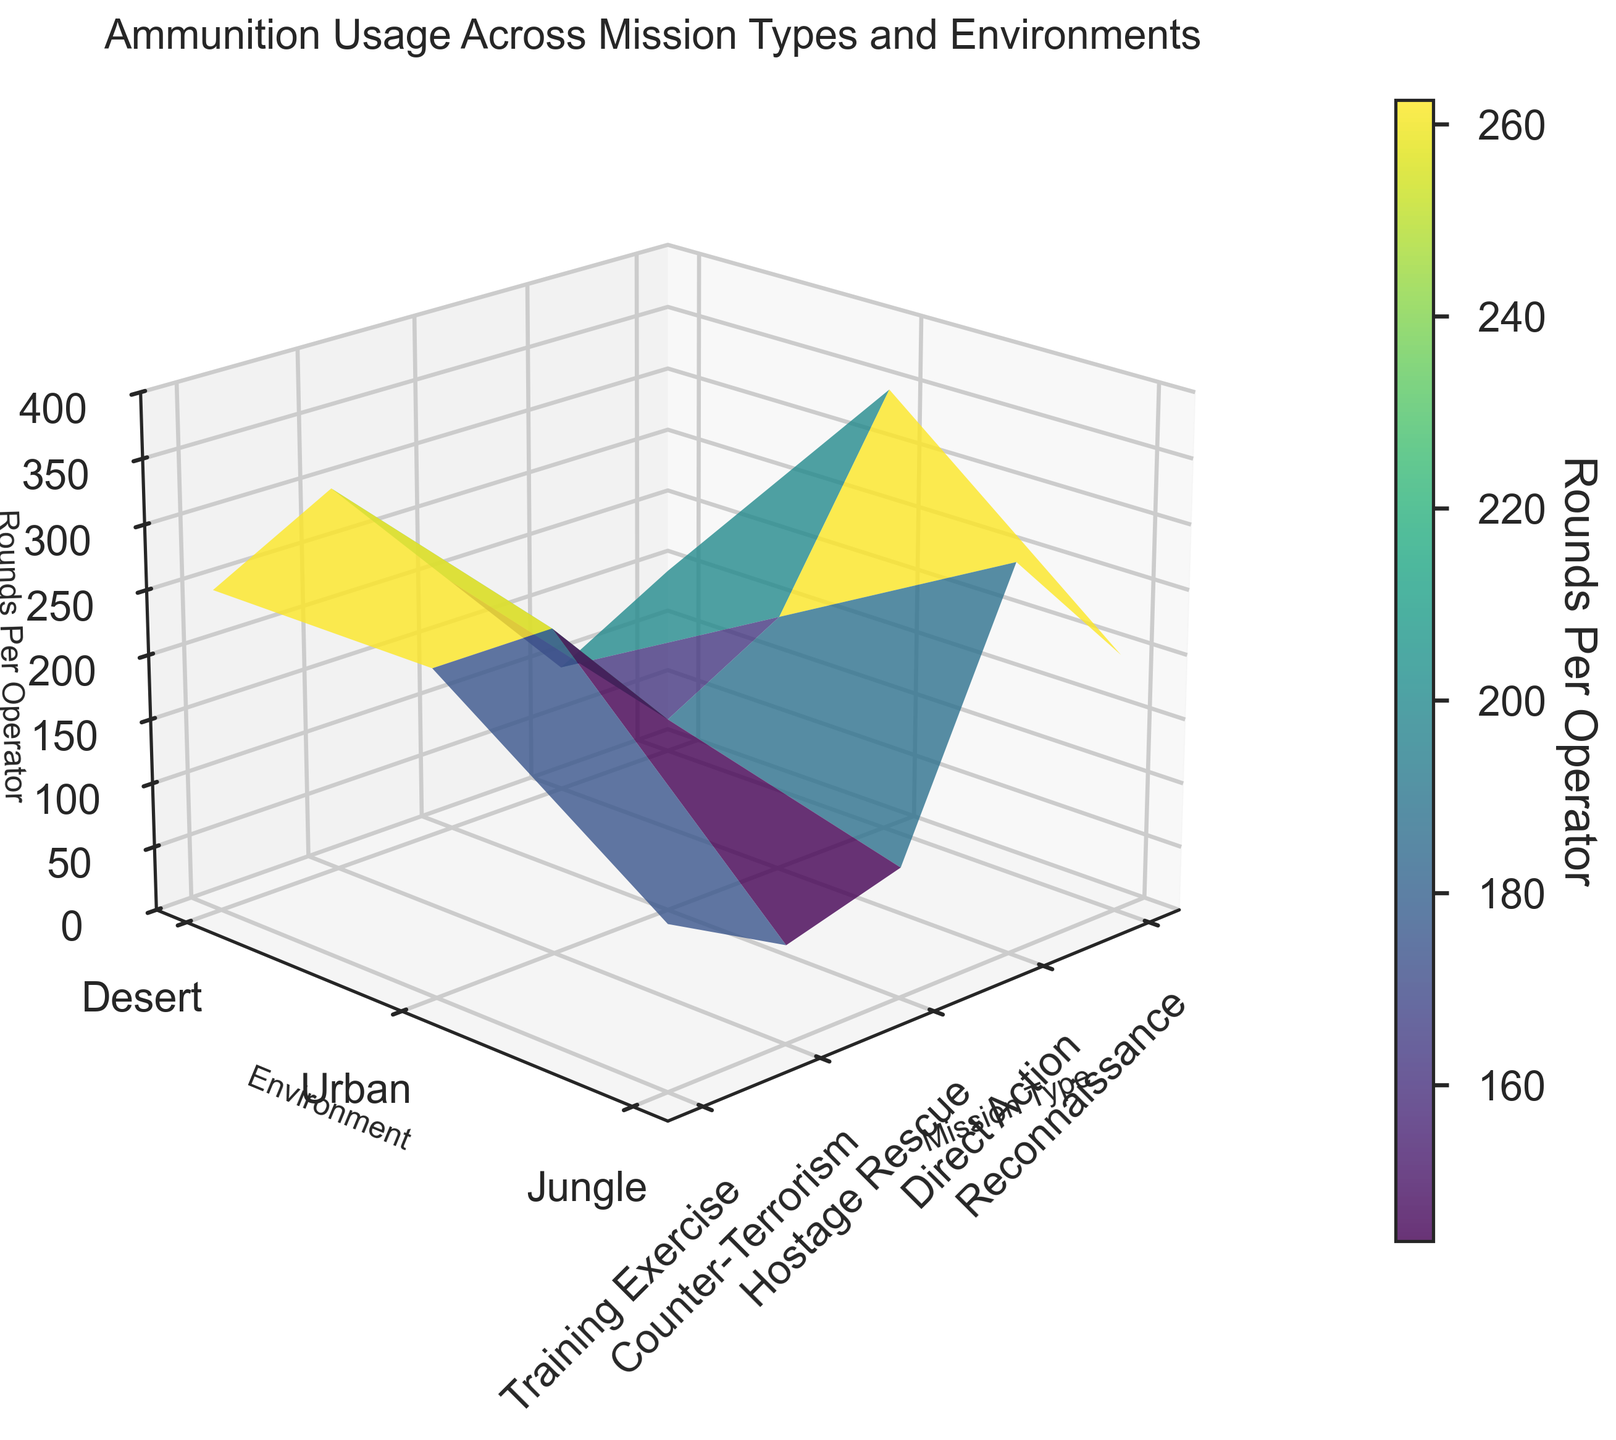What is the highest amount of rounds per operator in a jungle environment? Look for the peaks in the 'Jungle' section of the figure. The highest peak corresponds to the highest amount for the jungle. For 'Direct Action' in jungle, it’s at 350 rounds.
Answer: 350 Which mission type has the lowest ammunition usage in an urban environment? Identify the lowest points on the 'Urban' section of the plot. The 'Training Exercise' category has the lowest usage at 75 rounds per operator.
Answer: Training Exercise How does ammunition usage compare between 'Reconnaissance' and 'Direct Action' mission types in the desert environment? Compare the values along the desert (front row) for both mission types. 'Reconnaissance' has 150 rounds while 'Direct Action' has 300 rounds.
Answer: Direct Action uses 150 rounds more than Reconnaissance What is the average ammunition usage across all mission types in an urban environment? Identify ammunition values for each mission type in the Urban environment: (100, 250, 150, 200, 75). The average is calculated as (100+250+150+200+75)/5 = 775/5 = 155 rounds per operator.
Answer: 155 Which environment has the most variation in ammunition usage for 'Counter-Terrorism' missions? Compare usage across Desert (250), Urban (200), and Jungle (300). The difference between the maximum (300) and minimum (200) is 100, representing more variation in the jungle.
Answer: Jungle Is ammunition usage for 'Hostage Rescue' missions higher in the desert or urban environments? Compare the 'Hostage Rescue' points in Desert (200 rounds) and Urban (150 rounds). Desert has higher usage.
Answer: Desert For 'Training Exercise' missions, which environment uses the maximum amount of ammunition? Observe the highest point among the 'Training Exercise' sections for Desert (100), Urban (75), Jungle (125). The jungle has the maximum usage.
Answer: Jungle Which mission type shows the largest change in ammunition usage between desert and jungle environments? Compare the changes in ammunition across environments for each mission type. 'Direct Action' has the largest change from 300 rounds in Desert to 350 rounds in Jungle (50-round difference).
Answer: Direct Action What is the most common ammunition usage range across all mission types and environments? Visually identify the range where most data clusters. Observations show many values between 150 to 250 rounds per operator across various missions and environments.
Answer: 150 to 250 rounds Which combination of mission type and environment consistently shows higher usage of ammunition? Identify the combinations with notable high values. The 'Direct Action' mission type consistently shows higher usage across Desert, Urban, and Jungle.
Answer: Direct Action 